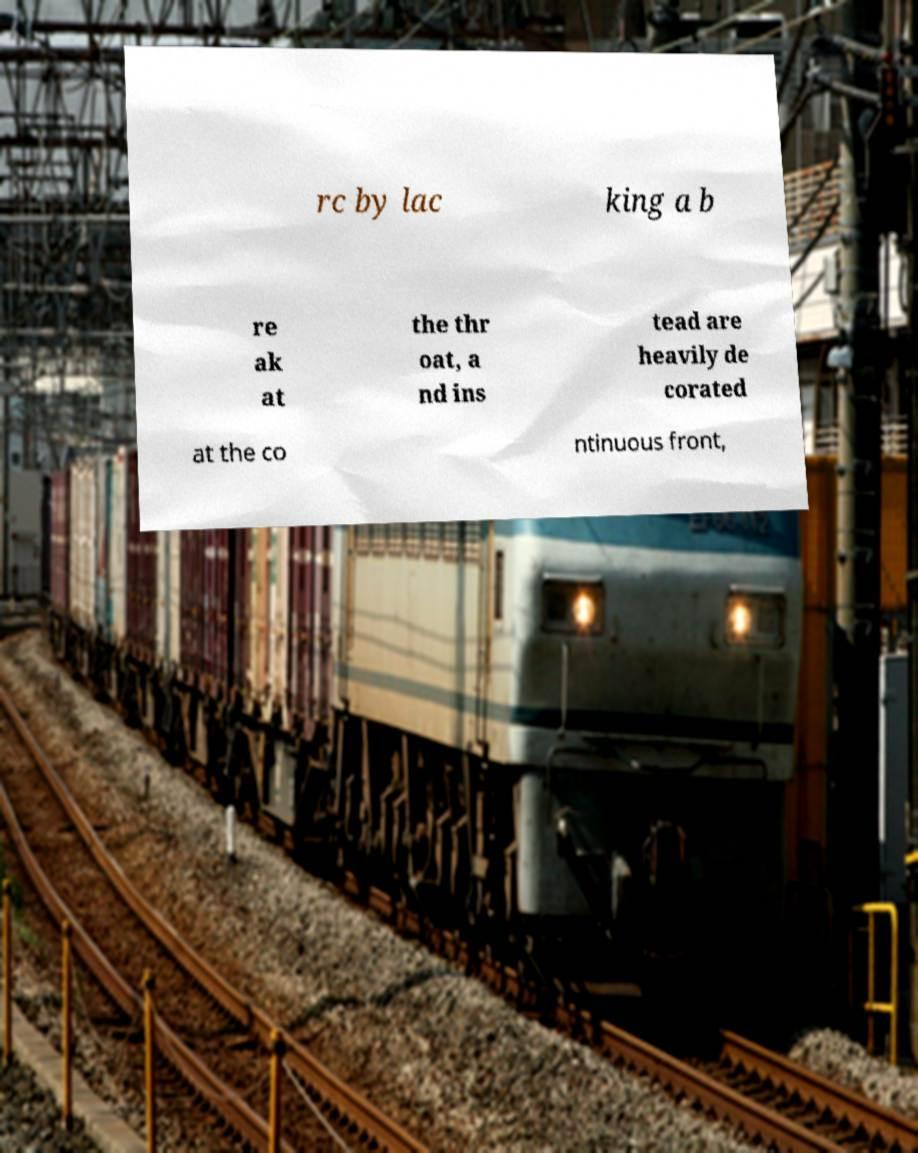Please read and relay the text visible in this image. What does it say? rc by lac king a b re ak at the thr oat, a nd ins tead are heavily de corated at the co ntinuous front, 